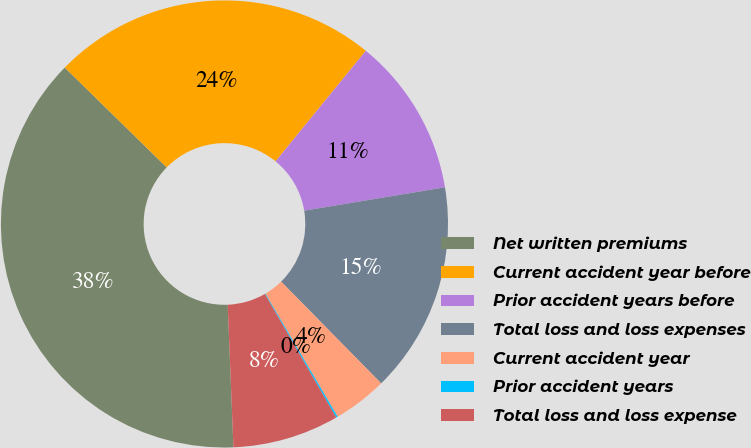Convert chart. <chart><loc_0><loc_0><loc_500><loc_500><pie_chart><fcel>Net written premiums<fcel>Current accident year before<fcel>Prior accident years before<fcel>Total loss and loss expenses<fcel>Current accident year<fcel>Prior accident years<fcel>Total loss and loss expense<nl><fcel>37.97%<fcel>23.56%<fcel>11.48%<fcel>15.26%<fcel>3.91%<fcel>0.12%<fcel>7.69%<nl></chart> 